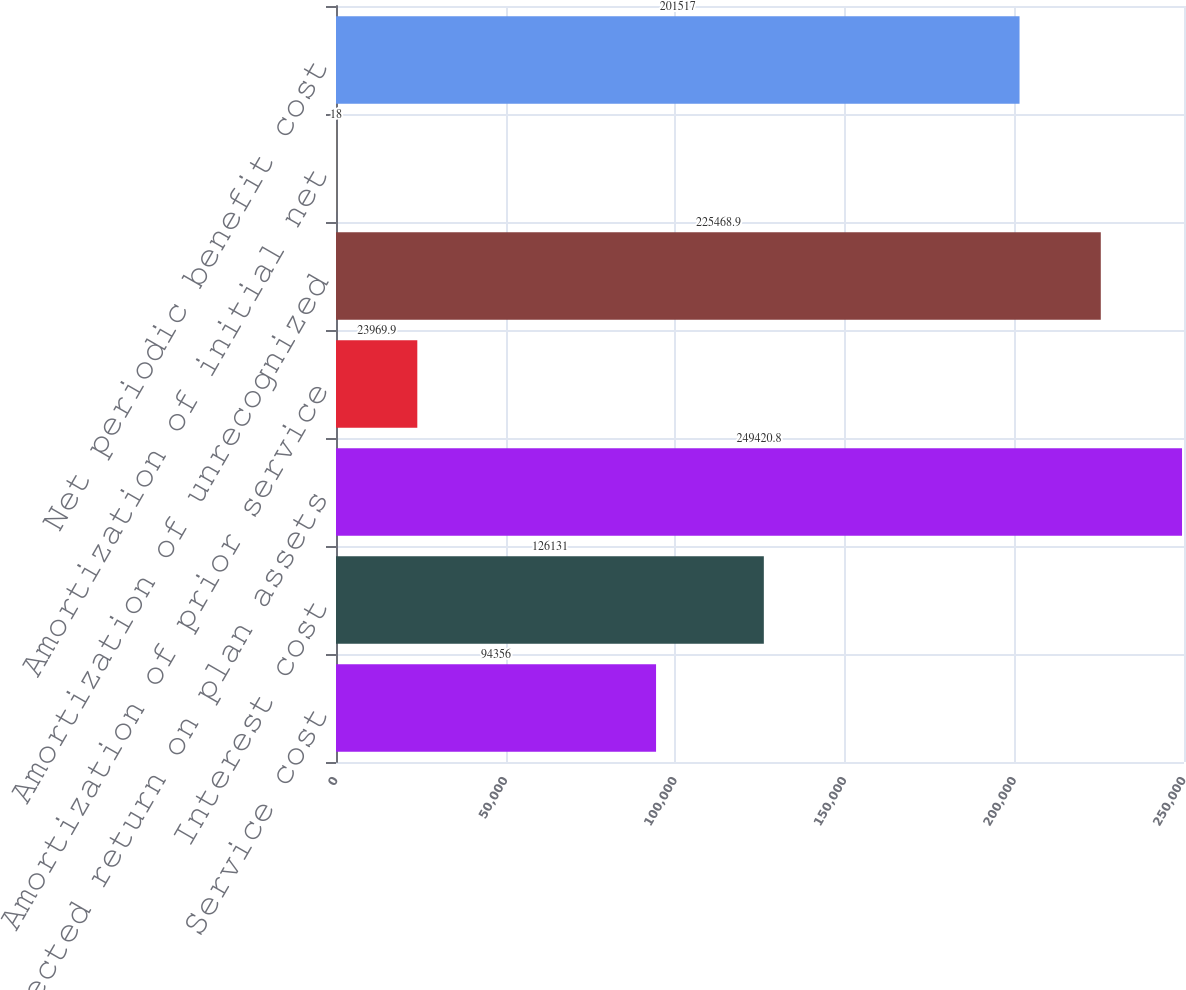<chart> <loc_0><loc_0><loc_500><loc_500><bar_chart><fcel>Service cost<fcel>Interest cost<fcel>Expected return on plan assets<fcel>Amortization of prior service<fcel>Amortization of unrecognized<fcel>Amortization of initial net<fcel>Net periodic benefit cost<nl><fcel>94356<fcel>126131<fcel>249421<fcel>23969.9<fcel>225469<fcel>18<fcel>201517<nl></chart> 